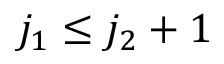<formula> <loc_0><loc_0><loc_500><loc_500>j _ { 1 } \leq j _ { 2 } + 1</formula> 